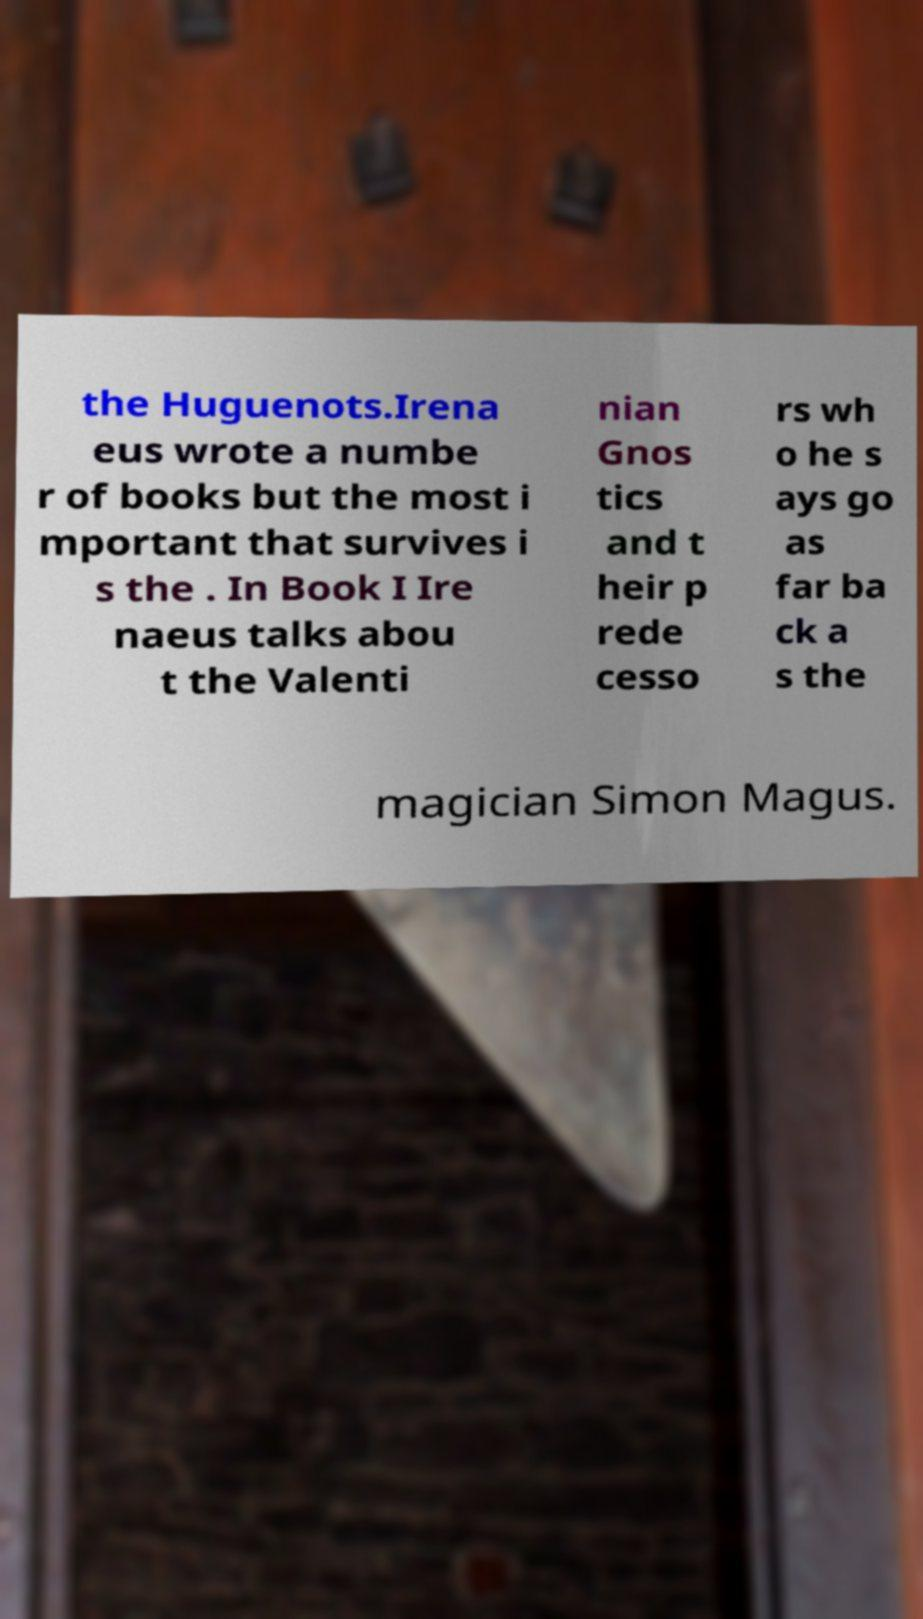Please read and relay the text visible in this image. What does it say? the Huguenots.Irena eus wrote a numbe r of books but the most i mportant that survives i s the . In Book I Ire naeus talks abou t the Valenti nian Gnos tics and t heir p rede cesso rs wh o he s ays go as far ba ck a s the magician Simon Magus. 